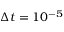Convert formula to latex. <formula><loc_0><loc_0><loc_500><loc_500>\Delta t = 1 0 ^ { - 5 }</formula> 